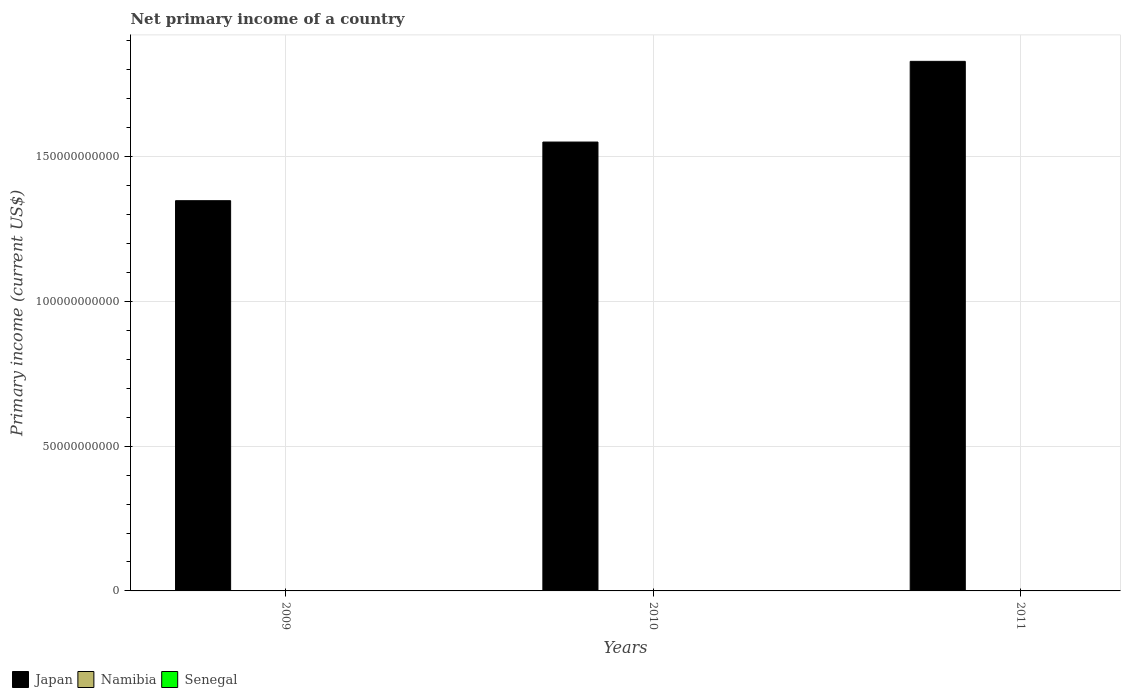Are the number of bars per tick equal to the number of legend labels?
Provide a short and direct response. No. Are the number of bars on each tick of the X-axis equal?
Offer a very short reply. Yes. How many bars are there on the 3rd tick from the left?
Ensure brevity in your answer.  1. What is the label of the 3rd group of bars from the left?
Your response must be concise. 2011. Across all years, what is the maximum primary income in Japan?
Give a very brief answer. 1.83e+11. Across all years, what is the minimum primary income in Japan?
Provide a short and direct response. 1.35e+11. In which year was the primary income in Japan maximum?
Keep it short and to the point. 2011. What is the total primary income in Senegal in the graph?
Keep it short and to the point. 0. What is the difference between the primary income in Japan in 2009 and that in 2011?
Provide a succinct answer. -4.81e+1. What is the difference between the primary income in Senegal in 2011 and the primary income in Namibia in 2009?
Make the answer very short. 0. What is the average primary income in Japan per year?
Ensure brevity in your answer.  1.58e+11. In how many years, is the primary income in Senegal greater than 110000000000 US$?
Give a very brief answer. 0. What is the ratio of the primary income in Japan in 2009 to that in 2011?
Make the answer very short. 0.74. What is the difference between the highest and the second highest primary income in Japan?
Make the answer very short. 2.79e+1. What is the difference between the highest and the lowest primary income in Japan?
Keep it short and to the point. 4.81e+1. In how many years, is the primary income in Namibia greater than the average primary income in Namibia taken over all years?
Provide a succinct answer. 0. Is the sum of the primary income in Japan in 2009 and 2011 greater than the maximum primary income in Senegal across all years?
Give a very brief answer. Yes. Is it the case that in every year, the sum of the primary income in Senegal and primary income in Japan is greater than the primary income in Namibia?
Offer a terse response. Yes. How many bars are there?
Keep it short and to the point. 3. Are all the bars in the graph horizontal?
Your answer should be very brief. No. How many years are there in the graph?
Ensure brevity in your answer.  3. Does the graph contain grids?
Provide a succinct answer. Yes. Where does the legend appear in the graph?
Your response must be concise. Bottom left. What is the title of the graph?
Give a very brief answer. Net primary income of a country. What is the label or title of the X-axis?
Your answer should be very brief. Years. What is the label or title of the Y-axis?
Make the answer very short. Primary income (current US$). What is the Primary income (current US$) of Japan in 2009?
Ensure brevity in your answer.  1.35e+11. What is the Primary income (current US$) in Namibia in 2009?
Make the answer very short. 0. What is the Primary income (current US$) in Japan in 2010?
Provide a short and direct response. 1.55e+11. What is the Primary income (current US$) in Namibia in 2010?
Your answer should be compact. 0. What is the Primary income (current US$) of Senegal in 2010?
Your response must be concise. 0. What is the Primary income (current US$) of Japan in 2011?
Offer a very short reply. 1.83e+11. What is the Primary income (current US$) in Namibia in 2011?
Ensure brevity in your answer.  0. What is the Primary income (current US$) in Senegal in 2011?
Give a very brief answer. 0. Across all years, what is the maximum Primary income (current US$) of Japan?
Provide a succinct answer. 1.83e+11. Across all years, what is the minimum Primary income (current US$) of Japan?
Your answer should be compact. 1.35e+11. What is the total Primary income (current US$) in Japan in the graph?
Keep it short and to the point. 4.73e+11. What is the total Primary income (current US$) in Namibia in the graph?
Your answer should be very brief. 0. What is the total Primary income (current US$) in Senegal in the graph?
Provide a succinct answer. 0. What is the difference between the Primary income (current US$) in Japan in 2009 and that in 2010?
Make the answer very short. -2.03e+1. What is the difference between the Primary income (current US$) in Japan in 2009 and that in 2011?
Give a very brief answer. -4.81e+1. What is the difference between the Primary income (current US$) of Japan in 2010 and that in 2011?
Give a very brief answer. -2.79e+1. What is the average Primary income (current US$) in Japan per year?
Your answer should be very brief. 1.58e+11. What is the ratio of the Primary income (current US$) in Japan in 2009 to that in 2010?
Give a very brief answer. 0.87. What is the ratio of the Primary income (current US$) of Japan in 2009 to that in 2011?
Your response must be concise. 0.74. What is the ratio of the Primary income (current US$) in Japan in 2010 to that in 2011?
Offer a terse response. 0.85. What is the difference between the highest and the second highest Primary income (current US$) of Japan?
Your answer should be very brief. 2.79e+1. What is the difference between the highest and the lowest Primary income (current US$) of Japan?
Keep it short and to the point. 4.81e+1. 